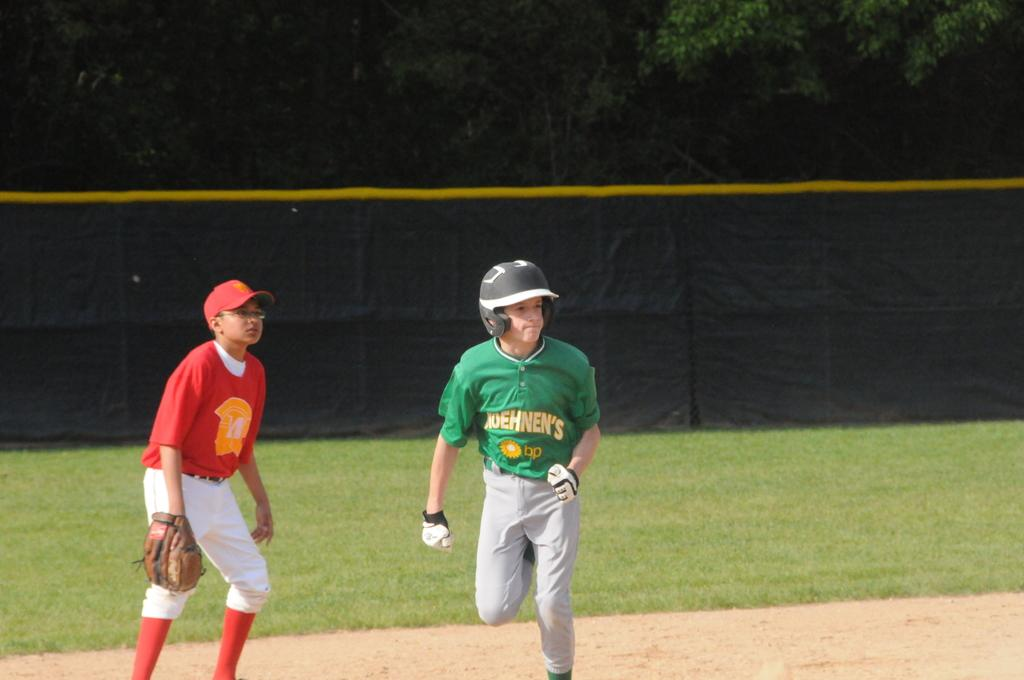How many people are in the image? There are two persons in the image. What are the persons wearing on their faces? The persons are wearing goggles. What type of surface is visible at the bottom of the image? There is ground visible at the bottom of the image. What type of vegetation can be seen in the background of the image? There are trees in the background of the image. What other elements can be seen in the background of the image? There is grass and cloth visible in the background of the image. What type of egg is being cooked in the stew in the image? There is no stew or egg present in the image; it features two persons wearing goggles and a background with trees, grass, and cloth. 